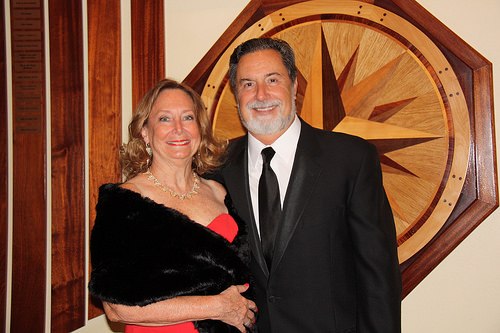<image>
Is there a man behind the picture frame? No. The man is not behind the picture frame. From this viewpoint, the man appears to be positioned elsewhere in the scene. 